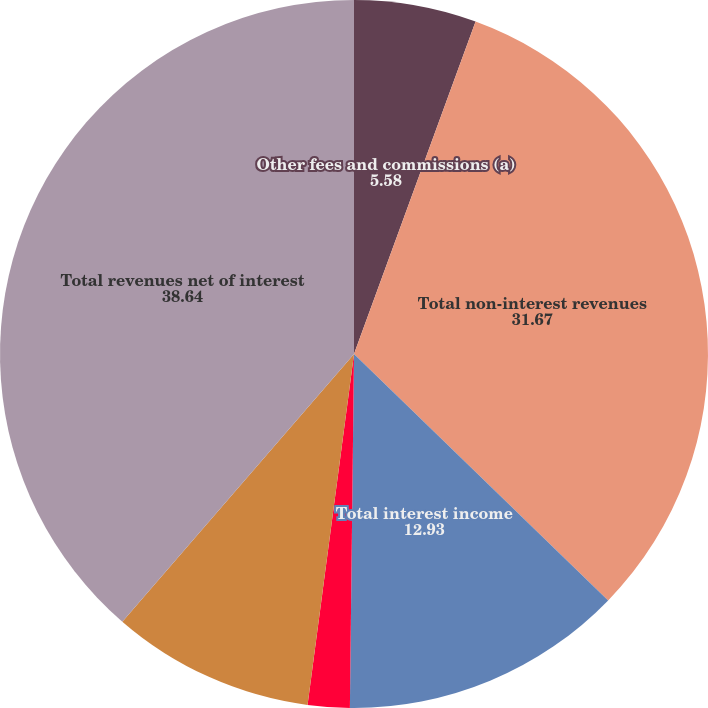<chart> <loc_0><loc_0><loc_500><loc_500><pie_chart><fcel>Other fees and commissions (a)<fcel>Total non-interest revenues<fcel>Total interest income<fcel>Total interest expense<fcel>Net interest income<fcel>Total revenues net of interest<nl><fcel>5.58%<fcel>31.67%<fcel>12.93%<fcel>1.91%<fcel>9.26%<fcel>38.64%<nl></chart> 